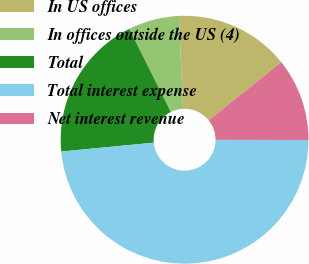Convert chart to OTSL. <chart><loc_0><loc_0><loc_500><loc_500><pie_chart><fcel>In US offices<fcel>In offices outside the US (4)<fcel>Total<fcel>Total interest expense<fcel>Net interest revenue<nl><fcel>14.98%<fcel>6.62%<fcel>19.16%<fcel>48.43%<fcel>10.8%<nl></chart> 